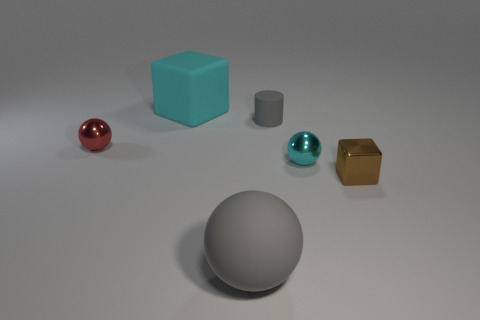Subtract all matte balls. How many balls are left? 2 Add 2 tiny purple blocks. How many objects exist? 8 Subtract all cylinders. How many objects are left? 5 Subtract all gray spheres. How many spheres are left? 2 Add 5 red shiny things. How many red shiny things are left? 6 Add 3 big green objects. How many big green objects exist? 3 Subtract 0 yellow cylinders. How many objects are left? 6 Subtract 1 balls. How many balls are left? 2 Subtract all blue balls. Subtract all green cylinders. How many balls are left? 3 Subtract all blue spheres. How many purple blocks are left? 0 